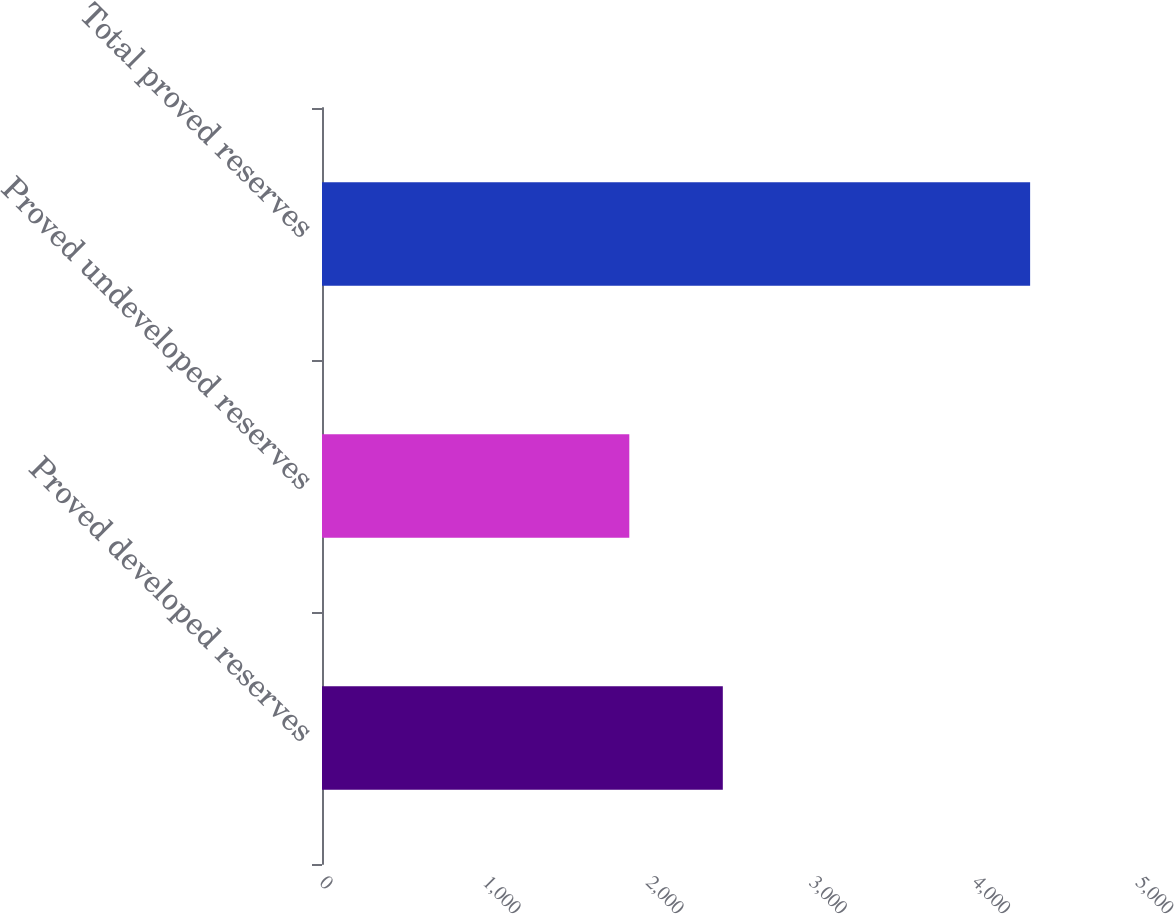Convert chart. <chart><loc_0><loc_0><loc_500><loc_500><bar_chart><fcel>Proved developed reserves<fcel>Proved undeveloped reserves<fcel>Total proved reserves<nl><fcel>2456<fcel>1883<fcel>4339<nl></chart> 